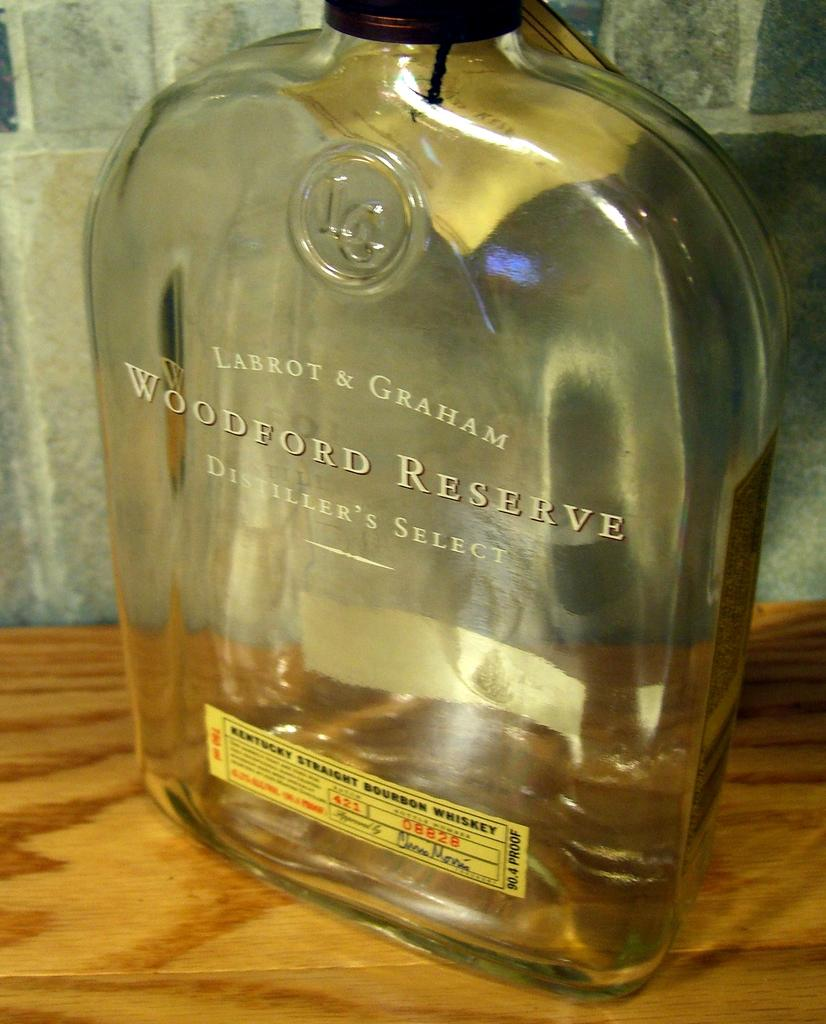<image>
Describe the image concisely. A bottle of Woodford Reserve wine sitting on wood table. 